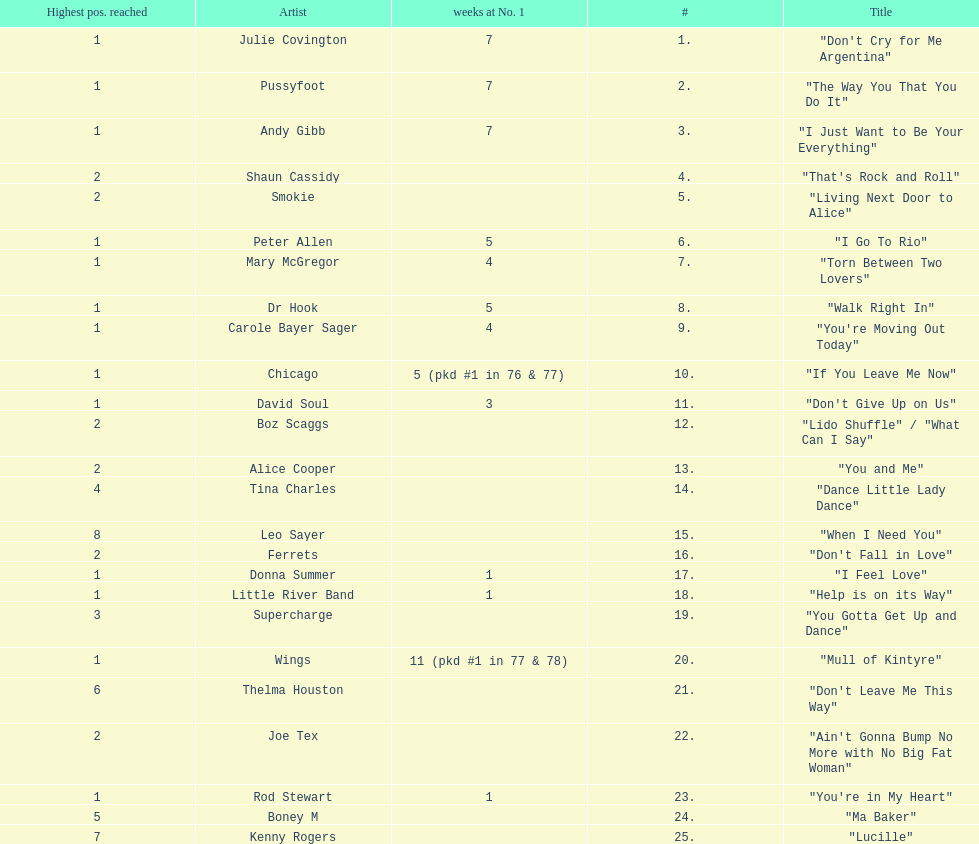Which song stayed at no.1 for the most amount of weeks. "Mull of Kintyre". 